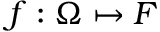Convert formula to latex. <formula><loc_0><loc_0><loc_500><loc_500>f \colon \Omega \mapsto F</formula> 